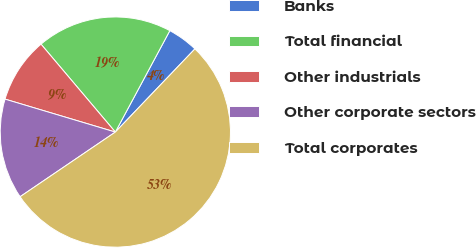<chart> <loc_0><loc_0><loc_500><loc_500><pie_chart><fcel>Banks<fcel>Total financial<fcel>Other industrials<fcel>Other corporate sectors<fcel>Total corporates<nl><fcel>4.3%<fcel>19.02%<fcel>9.21%<fcel>14.11%<fcel>53.36%<nl></chart> 